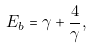<formula> <loc_0><loc_0><loc_500><loc_500>E _ { b } = \gamma + \frac { 4 } { \gamma } ,</formula> 